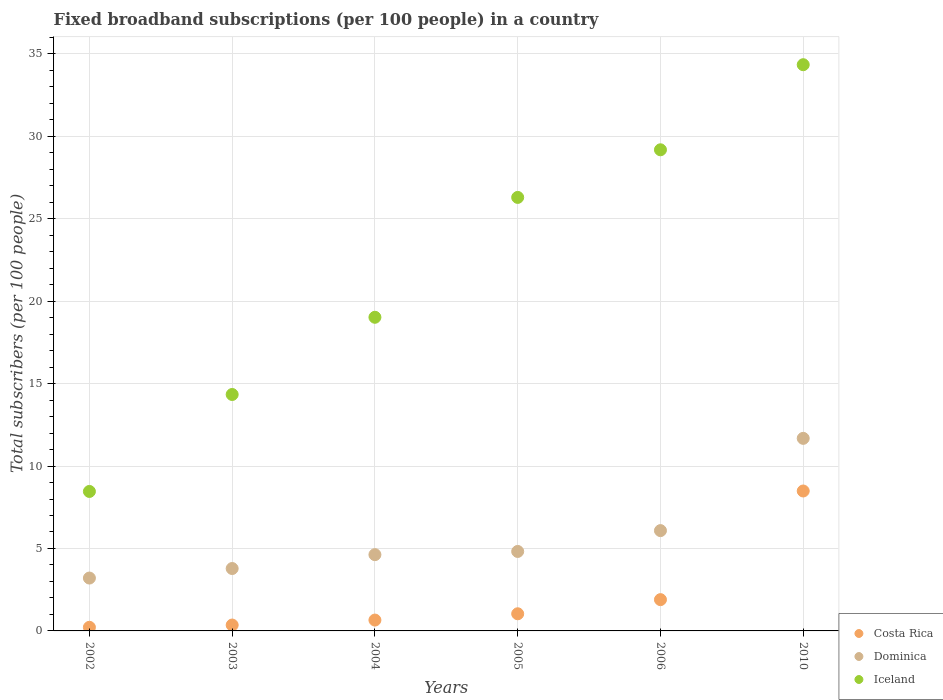Is the number of dotlines equal to the number of legend labels?
Keep it short and to the point. Yes. What is the number of broadband subscriptions in Costa Rica in 2002?
Offer a terse response. 0.22. Across all years, what is the maximum number of broadband subscriptions in Dominica?
Give a very brief answer. 11.68. Across all years, what is the minimum number of broadband subscriptions in Iceland?
Provide a succinct answer. 8.46. In which year was the number of broadband subscriptions in Iceland minimum?
Offer a very short reply. 2002. What is the total number of broadband subscriptions in Costa Rica in the graph?
Provide a succinct answer. 12.66. What is the difference between the number of broadband subscriptions in Iceland in 2005 and that in 2010?
Ensure brevity in your answer.  -8.05. What is the difference between the number of broadband subscriptions in Iceland in 2002 and the number of broadband subscriptions in Dominica in 2003?
Your answer should be very brief. 4.67. What is the average number of broadband subscriptions in Costa Rica per year?
Provide a succinct answer. 2.11. In the year 2002, what is the difference between the number of broadband subscriptions in Costa Rica and number of broadband subscriptions in Dominica?
Provide a succinct answer. -2.99. What is the ratio of the number of broadband subscriptions in Dominica in 2003 to that in 2006?
Make the answer very short. 0.62. Is the difference between the number of broadband subscriptions in Costa Rica in 2005 and 2006 greater than the difference between the number of broadband subscriptions in Dominica in 2005 and 2006?
Offer a very short reply. Yes. What is the difference between the highest and the second highest number of broadband subscriptions in Dominica?
Ensure brevity in your answer.  5.6. What is the difference between the highest and the lowest number of broadband subscriptions in Costa Rica?
Keep it short and to the point. 8.27. In how many years, is the number of broadband subscriptions in Iceland greater than the average number of broadband subscriptions in Iceland taken over all years?
Give a very brief answer. 3. Is the sum of the number of broadband subscriptions in Dominica in 2002 and 2006 greater than the maximum number of broadband subscriptions in Costa Rica across all years?
Your answer should be compact. Yes. Is it the case that in every year, the sum of the number of broadband subscriptions in Iceland and number of broadband subscriptions in Dominica  is greater than the number of broadband subscriptions in Costa Rica?
Keep it short and to the point. Yes. Is the number of broadband subscriptions in Dominica strictly greater than the number of broadband subscriptions in Costa Rica over the years?
Provide a succinct answer. Yes. How many dotlines are there?
Offer a very short reply. 3. How many years are there in the graph?
Keep it short and to the point. 6. Where does the legend appear in the graph?
Your answer should be compact. Bottom right. How are the legend labels stacked?
Ensure brevity in your answer.  Vertical. What is the title of the graph?
Give a very brief answer. Fixed broadband subscriptions (per 100 people) in a country. Does "Fiji" appear as one of the legend labels in the graph?
Provide a short and direct response. No. What is the label or title of the X-axis?
Give a very brief answer. Years. What is the label or title of the Y-axis?
Make the answer very short. Total subscribers (per 100 people). What is the Total subscribers (per 100 people) in Costa Rica in 2002?
Your answer should be very brief. 0.22. What is the Total subscribers (per 100 people) in Dominica in 2002?
Provide a succinct answer. 3.21. What is the Total subscribers (per 100 people) in Iceland in 2002?
Offer a terse response. 8.46. What is the Total subscribers (per 100 people) in Costa Rica in 2003?
Ensure brevity in your answer.  0.36. What is the Total subscribers (per 100 people) of Dominica in 2003?
Your answer should be very brief. 3.78. What is the Total subscribers (per 100 people) in Iceland in 2003?
Your answer should be very brief. 14.34. What is the Total subscribers (per 100 people) in Costa Rica in 2004?
Provide a succinct answer. 0.66. What is the Total subscribers (per 100 people) in Dominica in 2004?
Offer a very short reply. 4.63. What is the Total subscribers (per 100 people) in Iceland in 2004?
Your answer should be very brief. 19.02. What is the Total subscribers (per 100 people) in Costa Rica in 2005?
Offer a very short reply. 1.04. What is the Total subscribers (per 100 people) in Dominica in 2005?
Provide a succinct answer. 4.82. What is the Total subscribers (per 100 people) in Iceland in 2005?
Keep it short and to the point. 26.29. What is the Total subscribers (per 100 people) of Costa Rica in 2006?
Provide a short and direct response. 1.9. What is the Total subscribers (per 100 people) of Dominica in 2006?
Provide a succinct answer. 6.08. What is the Total subscribers (per 100 people) of Iceland in 2006?
Offer a very short reply. 29.18. What is the Total subscribers (per 100 people) in Costa Rica in 2010?
Your answer should be very brief. 8.49. What is the Total subscribers (per 100 people) of Dominica in 2010?
Offer a terse response. 11.68. What is the Total subscribers (per 100 people) of Iceland in 2010?
Offer a very short reply. 34.34. Across all years, what is the maximum Total subscribers (per 100 people) of Costa Rica?
Your answer should be very brief. 8.49. Across all years, what is the maximum Total subscribers (per 100 people) of Dominica?
Provide a short and direct response. 11.68. Across all years, what is the maximum Total subscribers (per 100 people) of Iceland?
Give a very brief answer. 34.34. Across all years, what is the minimum Total subscribers (per 100 people) in Costa Rica?
Offer a very short reply. 0.22. Across all years, what is the minimum Total subscribers (per 100 people) in Dominica?
Ensure brevity in your answer.  3.21. Across all years, what is the minimum Total subscribers (per 100 people) in Iceland?
Ensure brevity in your answer.  8.46. What is the total Total subscribers (per 100 people) in Costa Rica in the graph?
Give a very brief answer. 12.66. What is the total Total subscribers (per 100 people) in Dominica in the graph?
Keep it short and to the point. 34.2. What is the total Total subscribers (per 100 people) in Iceland in the graph?
Your answer should be compact. 131.63. What is the difference between the Total subscribers (per 100 people) in Costa Rica in 2002 and that in 2003?
Provide a short and direct response. -0.14. What is the difference between the Total subscribers (per 100 people) of Dominica in 2002 and that in 2003?
Provide a succinct answer. -0.58. What is the difference between the Total subscribers (per 100 people) of Iceland in 2002 and that in 2003?
Your answer should be very brief. -5.88. What is the difference between the Total subscribers (per 100 people) of Costa Rica in 2002 and that in 2004?
Ensure brevity in your answer.  -0.44. What is the difference between the Total subscribers (per 100 people) in Dominica in 2002 and that in 2004?
Ensure brevity in your answer.  -1.42. What is the difference between the Total subscribers (per 100 people) in Iceland in 2002 and that in 2004?
Your response must be concise. -10.56. What is the difference between the Total subscribers (per 100 people) in Costa Rica in 2002 and that in 2005?
Offer a terse response. -0.82. What is the difference between the Total subscribers (per 100 people) of Dominica in 2002 and that in 2005?
Keep it short and to the point. -1.61. What is the difference between the Total subscribers (per 100 people) in Iceland in 2002 and that in 2005?
Keep it short and to the point. -17.83. What is the difference between the Total subscribers (per 100 people) in Costa Rica in 2002 and that in 2006?
Your response must be concise. -1.68. What is the difference between the Total subscribers (per 100 people) of Dominica in 2002 and that in 2006?
Offer a terse response. -2.88. What is the difference between the Total subscribers (per 100 people) of Iceland in 2002 and that in 2006?
Keep it short and to the point. -20.72. What is the difference between the Total subscribers (per 100 people) of Costa Rica in 2002 and that in 2010?
Provide a succinct answer. -8.27. What is the difference between the Total subscribers (per 100 people) of Dominica in 2002 and that in 2010?
Offer a terse response. -8.47. What is the difference between the Total subscribers (per 100 people) of Iceland in 2002 and that in 2010?
Keep it short and to the point. -25.88. What is the difference between the Total subscribers (per 100 people) in Costa Rica in 2003 and that in 2004?
Make the answer very short. -0.3. What is the difference between the Total subscribers (per 100 people) in Dominica in 2003 and that in 2004?
Your response must be concise. -0.84. What is the difference between the Total subscribers (per 100 people) in Iceland in 2003 and that in 2004?
Provide a short and direct response. -4.68. What is the difference between the Total subscribers (per 100 people) of Costa Rica in 2003 and that in 2005?
Offer a very short reply. -0.68. What is the difference between the Total subscribers (per 100 people) in Dominica in 2003 and that in 2005?
Your answer should be compact. -1.04. What is the difference between the Total subscribers (per 100 people) in Iceland in 2003 and that in 2005?
Your response must be concise. -11.95. What is the difference between the Total subscribers (per 100 people) in Costa Rica in 2003 and that in 2006?
Keep it short and to the point. -1.54. What is the difference between the Total subscribers (per 100 people) of Dominica in 2003 and that in 2006?
Your answer should be compact. -2.3. What is the difference between the Total subscribers (per 100 people) of Iceland in 2003 and that in 2006?
Offer a very short reply. -14.84. What is the difference between the Total subscribers (per 100 people) of Costa Rica in 2003 and that in 2010?
Ensure brevity in your answer.  -8.13. What is the difference between the Total subscribers (per 100 people) of Dominica in 2003 and that in 2010?
Your answer should be very brief. -7.89. What is the difference between the Total subscribers (per 100 people) of Iceland in 2003 and that in 2010?
Your response must be concise. -20. What is the difference between the Total subscribers (per 100 people) in Costa Rica in 2004 and that in 2005?
Offer a terse response. -0.38. What is the difference between the Total subscribers (per 100 people) of Dominica in 2004 and that in 2005?
Provide a short and direct response. -0.19. What is the difference between the Total subscribers (per 100 people) in Iceland in 2004 and that in 2005?
Offer a terse response. -7.27. What is the difference between the Total subscribers (per 100 people) in Costa Rica in 2004 and that in 2006?
Provide a short and direct response. -1.24. What is the difference between the Total subscribers (per 100 people) in Dominica in 2004 and that in 2006?
Give a very brief answer. -1.46. What is the difference between the Total subscribers (per 100 people) in Iceland in 2004 and that in 2006?
Give a very brief answer. -10.16. What is the difference between the Total subscribers (per 100 people) in Costa Rica in 2004 and that in 2010?
Provide a short and direct response. -7.83. What is the difference between the Total subscribers (per 100 people) in Dominica in 2004 and that in 2010?
Provide a succinct answer. -7.05. What is the difference between the Total subscribers (per 100 people) in Iceland in 2004 and that in 2010?
Ensure brevity in your answer.  -15.32. What is the difference between the Total subscribers (per 100 people) of Costa Rica in 2005 and that in 2006?
Your answer should be compact. -0.86. What is the difference between the Total subscribers (per 100 people) in Dominica in 2005 and that in 2006?
Provide a short and direct response. -1.26. What is the difference between the Total subscribers (per 100 people) of Iceland in 2005 and that in 2006?
Keep it short and to the point. -2.89. What is the difference between the Total subscribers (per 100 people) of Costa Rica in 2005 and that in 2010?
Keep it short and to the point. -7.45. What is the difference between the Total subscribers (per 100 people) in Dominica in 2005 and that in 2010?
Your answer should be very brief. -6.86. What is the difference between the Total subscribers (per 100 people) of Iceland in 2005 and that in 2010?
Your answer should be compact. -8.05. What is the difference between the Total subscribers (per 100 people) in Costa Rica in 2006 and that in 2010?
Your answer should be very brief. -6.59. What is the difference between the Total subscribers (per 100 people) in Dominica in 2006 and that in 2010?
Provide a succinct answer. -5.6. What is the difference between the Total subscribers (per 100 people) of Iceland in 2006 and that in 2010?
Offer a terse response. -5.16. What is the difference between the Total subscribers (per 100 people) in Costa Rica in 2002 and the Total subscribers (per 100 people) in Dominica in 2003?
Your response must be concise. -3.56. What is the difference between the Total subscribers (per 100 people) in Costa Rica in 2002 and the Total subscribers (per 100 people) in Iceland in 2003?
Offer a very short reply. -14.12. What is the difference between the Total subscribers (per 100 people) of Dominica in 2002 and the Total subscribers (per 100 people) of Iceland in 2003?
Offer a very short reply. -11.13. What is the difference between the Total subscribers (per 100 people) of Costa Rica in 2002 and the Total subscribers (per 100 people) of Dominica in 2004?
Your response must be concise. -4.41. What is the difference between the Total subscribers (per 100 people) of Costa Rica in 2002 and the Total subscribers (per 100 people) of Iceland in 2004?
Ensure brevity in your answer.  -18.8. What is the difference between the Total subscribers (per 100 people) in Dominica in 2002 and the Total subscribers (per 100 people) in Iceland in 2004?
Ensure brevity in your answer.  -15.81. What is the difference between the Total subscribers (per 100 people) in Costa Rica in 2002 and the Total subscribers (per 100 people) in Dominica in 2005?
Provide a short and direct response. -4.6. What is the difference between the Total subscribers (per 100 people) in Costa Rica in 2002 and the Total subscribers (per 100 people) in Iceland in 2005?
Give a very brief answer. -26.07. What is the difference between the Total subscribers (per 100 people) of Dominica in 2002 and the Total subscribers (per 100 people) of Iceland in 2005?
Give a very brief answer. -23.08. What is the difference between the Total subscribers (per 100 people) of Costa Rica in 2002 and the Total subscribers (per 100 people) of Dominica in 2006?
Make the answer very short. -5.86. What is the difference between the Total subscribers (per 100 people) of Costa Rica in 2002 and the Total subscribers (per 100 people) of Iceland in 2006?
Offer a terse response. -28.96. What is the difference between the Total subscribers (per 100 people) in Dominica in 2002 and the Total subscribers (per 100 people) in Iceland in 2006?
Your answer should be compact. -25.97. What is the difference between the Total subscribers (per 100 people) in Costa Rica in 2002 and the Total subscribers (per 100 people) in Dominica in 2010?
Ensure brevity in your answer.  -11.46. What is the difference between the Total subscribers (per 100 people) in Costa Rica in 2002 and the Total subscribers (per 100 people) in Iceland in 2010?
Ensure brevity in your answer.  -34.12. What is the difference between the Total subscribers (per 100 people) of Dominica in 2002 and the Total subscribers (per 100 people) of Iceland in 2010?
Offer a terse response. -31.13. What is the difference between the Total subscribers (per 100 people) in Costa Rica in 2003 and the Total subscribers (per 100 people) in Dominica in 2004?
Keep it short and to the point. -4.27. What is the difference between the Total subscribers (per 100 people) in Costa Rica in 2003 and the Total subscribers (per 100 people) in Iceland in 2004?
Keep it short and to the point. -18.66. What is the difference between the Total subscribers (per 100 people) of Dominica in 2003 and the Total subscribers (per 100 people) of Iceland in 2004?
Your answer should be very brief. -15.24. What is the difference between the Total subscribers (per 100 people) of Costa Rica in 2003 and the Total subscribers (per 100 people) of Dominica in 2005?
Keep it short and to the point. -4.46. What is the difference between the Total subscribers (per 100 people) in Costa Rica in 2003 and the Total subscribers (per 100 people) in Iceland in 2005?
Provide a succinct answer. -25.93. What is the difference between the Total subscribers (per 100 people) of Dominica in 2003 and the Total subscribers (per 100 people) of Iceland in 2005?
Your answer should be compact. -22.51. What is the difference between the Total subscribers (per 100 people) in Costa Rica in 2003 and the Total subscribers (per 100 people) in Dominica in 2006?
Keep it short and to the point. -5.73. What is the difference between the Total subscribers (per 100 people) in Costa Rica in 2003 and the Total subscribers (per 100 people) in Iceland in 2006?
Keep it short and to the point. -28.82. What is the difference between the Total subscribers (per 100 people) of Dominica in 2003 and the Total subscribers (per 100 people) of Iceland in 2006?
Provide a succinct answer. -25.39. What is the difference between the Total subscribers (per 100 people) in Costa Rica in 2003 and the Total subscribers (per 100 people) in Dominica in 2010?
Provide a succinct answer. -11.32. What is the difference between the Total subscribers (per 100 people) of Costa Rica in 2003 and the Total subscribers (per 100 people) of Iceland in 2010?
Offer a very short reply. -33.98. What is the difference between the Total subscribers (per 100 people) in Dominica in 2003 and the Total subscribers (per 100 people) in Iceland in 2010?
Give a very brief answer. -30.55. What is the difference between the Total subscribers (per 100 people) in Costa Rica in 2004 and the Total subscribers (per 100 people) in Dominica in 2005?
Give a very brief answer. -4.16. What is the difference between the Total subscribers (per 100 people) of Costa Rica in 2004 and the Total subscribers (per 100 people) of Iceland in 2005?
Provide a short and direct response. -25.63. What is the difference between the Total subscribers (per 100 people) of Dominica in 2004 and the Total subscribers (per 100 people) of Iceland in 2005?
Provide a short and direct response. -21.67. What is the difference between the Total subscribers (per 100 people) in Costa Rica in 2004 and the Total subscribers (per 100 people) in Dominica in 2006?
Offer a very short reply. -5.43. What is the difference between the Total subscribers (per 100 people) of Costa Rica in 2004 and the Total subscribers (per 100 people) of Iceland in 2006?
Keep it short and to the point. -28.52. What is the difference between the Total subscribers (per 100 people) of Dominica in 2004 and the Total subscribers (per 100 people) of Iceland in 2006?
Your response must be concise. -24.55. What is the difference between the Total subscribers (per 100 people) of Costa Rica in 2004 and the Total subscribers (per 100 people) of Dominica in 2010?
Make the answer very short. -11.02. What is the difference between the Total subscribers (per 100 people) of Costa Rica in 2004 and the Total subscribers (per 100 people) of Iceland in 2010?
Ensure brevity in your answer.  -33.68. What is the difference between the Total subscribers (per 100 people) in Dominica in 2004 and the Total subscribers (per 100 people) in Iceland in 2010?
Your answer should be compact. -29.71. What is the difference between the Total subscribers (per 100 people) in Costa Rica in 2005 and the Total subscribers (per 100 people) in Dominica in 2006?
Offer a terse response. -5.04. What is the difference between the Total subscribers (per 100 people) in Costa Rica in 2005 and the Total subscribers (per 100 people) in Iceland in 2006?
Ensure brevity in your answer.  -28.14. What is the difference between the Total subscribers (per 100 people) of Dominica in 2005 and the Total subscribers (per 100 people) of Iceland in 2006?
Give a very brief answer. -24.36. What is the difference between the Total subscribers (per 100 people) in Costa Rica in 2005 and the Total subscribers (per 100 people) in Dominica in 2010?
Provide a succinct answer. -10.64. What is the difference between the Total subscribers (per 100 people) of Costa Rica in 2005 and the Total subscribers (per 100 people) of Iceland in 2010?
Make the answer very short. -33.3. What is the difference between the Total subscribers (per 100 people) in Dominica in 2005 and the Total subscribers (per 100 people) in Iceland in 2010?
Your answer should be very brief. -29.52. What is the difference between the Total subscribers (per 100 people) in Costa Rica in 2006 and the Total subscribers (per 100 people) in Dominica in 2010?
Your answer should be very brief. -9.78. What is the difference between the Total subscribers (per 100 people) in Costa Rica in 2006 and the Total subscribers (per 100 people) in Iceland in 2010?
Offer a terse response. -32.44. What is the difference between the Total subscribers (per 100 people) in Dominica in 2006 and the Total subscribers (per 100 people) in Iceland in 2010?
Your answer should be compact. -28.26. What is the average Total subscribers (per 100 people) of Costa Rica per year?
Make the answer very short. 2.11. What is the average Total subscribers (per 100 people) in Dominica per year?
Provide a short and direct response. 5.7. What is the average Total subscribers (per 100 people) in Iceland per year?
Offer a terse response. 21.94. In the year 2002, what is the difference between the Total subscribers (per 100 people) in Costa Rica and Total subscribers (per 100 people) in Dominica?
Make the answer very short. -2.99. In the year 2002, what is the difference between the Total subscribers (per 100 people) in Costa Rica and Total subscribers (per 100 people) in Iceland?
Your answer should be compact. -8.24. In the year 2002, what is the difference between the Total subscribers (per 100 people) of Dominica and Total subscribers (per 100 people) of Iceland?
Ensure brevity in your answer.  -5.25. In the year 2003, what is the difference between the Total subscribers (per 100 people) of Costa Rica and Total subscribers (per 100 people) of Dominica?
Keep it short and to the point. -3.43. In the year 2003, what is the difference between the Total subscribers (per 100 people) in Costa Rica and Total subscribers (per 100 people) in Iceland?
Give a very brief answer. -13.98. In the year 2003, what is the difference between the Total subscribers (per 100 people) of Dominica and Total subscribers (per 100 people) of Iceland?
Keep it short and to the point. -10.55. In the year 2004, what is the difference between the Total subscribers (per 100 people) of Costa Rica and Total subscribers (per 100 people) of Dominica?
Your answer should be very brief. -3.97. In the year 2004, what is the difference between the Total subscribers (per 100 people) of Costa Rica and Total subscribers (per 100 people) of Iceland?
Your answer should be compact. -18.36. In the year 2004, what is the difference between the Total subscribers (per 100 people) of Dominica and Total subscribers (per 100 people) of Iceland?
Ensure brevity in your answer.  -14.4. In the year 2005, what is the difference between the Total subscribers (per 100 people) in Costa Rica and Total subscribers (per 100 people) in Dominica?
Give a very brief answer. -3.78. In the year 2005, what is the difference between the Total subscribers (per 100 people) of Costa Rica and Total subscribers (per 100 people) of Iceland?
Provide a succinct answer. -25.25. In the year 2005, what is the difference between the Total subscribers (per 100 people) of Dominica and Total subscribers (per 100 people) of Iceland?
Keep it short and to the point. -21.47. In the year 2006, what is the difference between the Total subscribers (per 100 people) of Costa Rica and Total subscribers (per 100 people) of Dominica?
Give a very brief answer. -4.19. In the year 2006, what is the difference between the Total subscribers (per 100 people) of Costa Rica and Total subscribers (per 100 people) of Iceland?
Make the answer very short. -27.28. In the year 2006, what is the difference between the Total subscribers (per 100 people) of Dominica and Total subscribers (per 100 people) of Iceland?
Offer a terse response. -23.1. In the year 2010, what is the difference between the Total subscribers (per 100 people) of Costa Rica and Total subscribers (per 100 people) of Dominica?
Give a very brief answer. -3.19. In the year 2010, what is the difference between the Total subscribers (per 100 people) of Costa Rica and Total subscribers (per 100 people) of Iceland?
Provide a short and direct response. -25.85. In the year 2010, what is the difference between the Total subscribers (per 100 people) in Dominica and Total subscribers (per 100 people) in Iceland?
Keep it short and to the point. -22.66. What is the ratio of the Total subscribers (per 100 people) of Costa Rica in 2002 to that in 2003?
Offer a very short reply. 0.62. What is the ratio of the Total subscribers (per 100 people) in Dominica in 2002 to that in 2003?
Your response must be concise. 0.85. What is the ratio of the Total subscribers (per 100 people) in Iceland in 2002 to that in 2003?
Give a very brief answer. 0.59. What is the ratio of the Total subscribers (per 100 people) of Costa Rica in 2002 to that in 2004?
Your answer should be very brief. 0.33. What is the ratio of the Total subscribers (per 100 people) in Dominica in 2002 to that in 2004?
Provide a short and direct response. 0.69. What is the ratio of the Total subscribers (per 100 people) in Iceland in 2002 to that in 2004?
Give a very brief answer. 0.44. What is the ratio of the Total subscribers (per 100 people) of Costa Rica in 2002 to that in 2005?
Your response must be concise. 0.21. What is the ratio of the Total subscribers (per 100 people) in Dominica in 2002 to that in 2005?
Your response must be concise. 0.67. What is the ratio of the Total subscribers (per 100 people) of Iceland in 2002 to that in 2005?
Make the answer very short. 0.32. What is the ratio of the Total subscribers (per 100 people) of Costa Rica in 2002 to that in 2006?
Provide a succinct answer. 0.12. What is the ratio of the Total subscribers (per 100 people) of Dominica in 2002 to that in 2006?
Your answer should be very brief. 0.53. What is the ratio of the Total subscribers (per 100 people) in Iceland in 2002 to that in 2006?
Your answer should be very brief. 0.29. What is the ratio of the Total subscribers (per 100 people) of Costa Rica in 2002 to that in 2010?
Make the answer very short. 0.03. What is the ratio of the Total subscribers (per 100 people) of Dominica in 2002 to that in 2010?
Your answer should be compact. 0.27. What is the ratio of the Total subscribers (per 100 people) of Iceland in 2002 to that in 2010?
Keep it short and to the point. 0.25. What is the ratio of the Total subscribers (per 100 people) of Costa Rica in 2003 to that in 2004?
Make the answer very short. 0.54. What is the ratio of the Total subscribers (per 100 people) in Dominica in 2003 to that in 2004?
Give a very brief answer. 0.82. What is the ratio of the Total subscribers (per 100 people) in Iceland in 2003 to that in 2004?
Provide a short and direct response. 0.75. What is the ratio of the Total subscribers (per 100 people) of Costa Rica in 2003 to that in 2005?
Keep it short and to the point. 0.34. What is the ratio of the Total subscribers (per 100 people) in Dominica in 2003 to that in 2005?
Provide a succinct answer. 0.79. What is the ratio of the Total subscribers (per 100 people) in Iceland in 2003 to that in 2005?
Keep it short and to the point. 0.55. What is the ratio of the Total subscribers (per 100 people) of Costa Rica in 2003 to that in 2006?
Your answer should be very brief. 0.19. What is the ratio of the Total subscribers (per 100 people) of Dominica in 2003 to that in 2006?
Your answer should be very brief. 0.62. What is the ratio of the Total subscribers (per 100 people) in Iceland in 2003 to that in 2006?
Your response must be concise. 0.49. What is the ratio of the Total subscribers (per 100 people) of Costa Rica in 2003 to that in 2010?
Your answer should be compact. 0.04. What is the ratio of the Total subscribers (per 100 people) in Dominica in 2003 to that in 2010?
Your answer should be compact. 0.32. What is the ratio of the Total subscribers (per 100 people) in Iceland in 2003 to that in 2010?
Your response must be concise. 0.42. What is the ratio of the Total subscribers (per 100 people) in Costa Rica in 2004 to that in 2005?
Make the answer very short. 0.63. What is the ratio of the Total subscribers (per 100 people) in Dominica in 2004 to that in 2005?
Your answer should be compact. 0.96. What is the ratio of the Total subscribers (per 100 people) of Iceland in 2004 to that in 2005?
Offer a very short reply. 0.72. What is the ratio of the Total subscribers (per 100 people) of Costa Rica in 2004 to that in 2006?
Ensure brevity in your answer.  0.35. What is the ratio of the Total subscribers (per 100 people) in Dominica in 2004 to that in 2006?
Offer a terse response. 0.76. What is the ratio of the Total subscribers (per 100 people) of Iceland in 2004 to that in 2006?
Provide a short and direct response. 0.65. What is the ratio of the Total subscribers (per 100 people) of Costa Rica in 2004 to that in 2010?
Make the answer very short. 0.08. What is the ratio of the Total subscribers (per 100 people) of Dominica in 2004 to that in 2010?
Give a very brief answer. 0.4. What is the ratio of the Total subscribers (per 100 people) of Iceland in 2004 to that in 2010?
Provide a short and direct response. 0.55. What is the ratio of the Total subscribers (per 100 people) of Costa Rica in 2005 to that in 2006?
Provide a short and direct response. 0.55. What is the ratio of the Total subscribers (per 100 people) in Dominica in 2005 to that in 2006?
Keep it short and to the point. 0.79. What is the ratio of the Total subscribers (per 100 people) in Iceland in 2005 to that in 2006?
Give a very brief answer. 0.9. What is the ratio of the Total subscribers (per 100 people) in Costa Rica in 2005 to that in 2010?
Keep it short and to the point. 0.12. What is the ratio of the Total subscribers (per 100 people) of Dominica in 2005 to that in 2010?
Ensure brevity in your answer.  0.41. What is the ratio of the Total subscribers (per 100 people) in Iceland in 2005 to that in 2010?
Your response must be concise. 0.77. What is the ratio of the Total subscribers (per 100 people) in Costa Rica in 2006 to that in 2010?
Ensure brevity in your answer.  0.22. What is the ratio of the Total subscribers (per 100 people) of Dominica in 2006 to that in 2010?
Offer a very short reply. 0.52. What is the ratio of the Total subscribers (per 100 people) in Iceland in 2006 to that in 2010?
Ensure brevity in your answer.  0.85. What is the difference between the highest and the second highest Total subscribers (per 100 people) in Costa Rica?
Offer a very short reply. 6.59. What is the difference between the highest and the second highest Total subscribers (per 100 people) in Dominica?
Ensure brevity in your answer.  5.6. What is the difference between the highest and the second highest Total subscribers (per 100 people) in Iceland?
Your answer should be very brief. 5.16. What is the difference between the highest and the lowest Total subscribers (per 100 people) in Costa Rica?
Keep it short and to the point. 8.27. What is the difference between the highest and the lowest Total subscribers (per 100 people) in Dominica?
Your answer should be compact. 8.47. What is the difference between the highest and the lowest Total subscribers (per 100 people) in Iceland?
Make the answer very short. 25.88. 